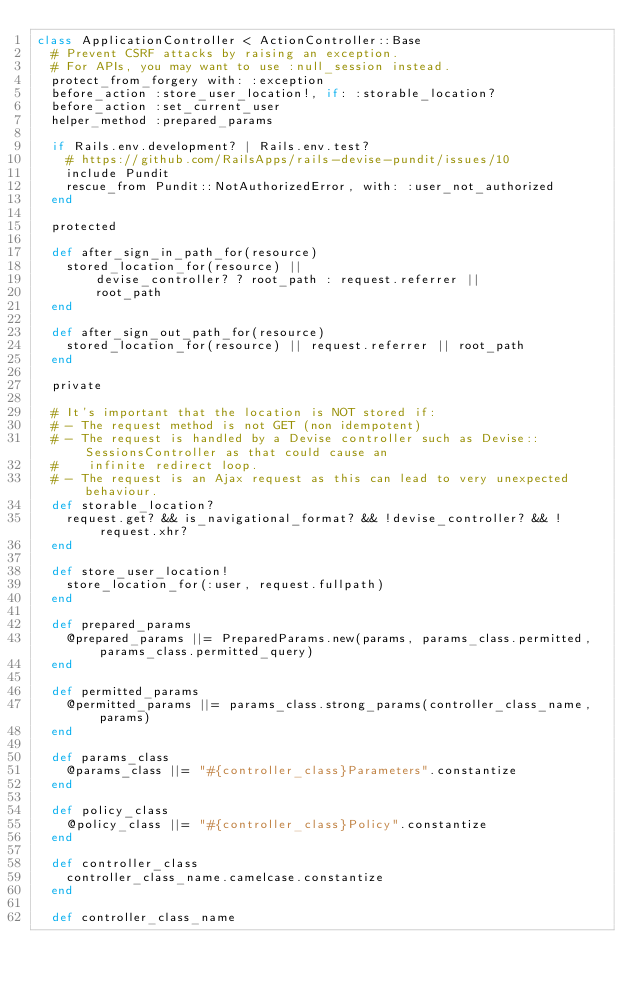<code> <loc_0><loc_0><loc_500><loc_500><_Ruby_>class ApplicationController < ActionController::Base
  # Prevent CSRF attacks by raising an exception.
  # For APIs, you may want to use :null_session instead.
  protect_from_forgery with: :exception
  before_action :store_user_location!, if: :storable_location?
  before_action :set_current_user
  helper_method :prepared_params

  if Rails.env.development? | Rails.env.test?
    # https://github.com/RailsApps/rails-devise-pundit/issues/10
    include Pundit
    rescue_from Pundit::NotAuthorizedError, with: :user_not_authorized
  end

  protected

  def after_sign_in_path_for(resource)
    stored_location_for(resource) ||
        devise_controller? ? root_path : request.referrer ||
        root_path
  end

  def after_sign_out_path_for(resource)
    stored_location_for(resource) || request.referrer || root_path
  end

  private

  # It's important that the location is NOT stored if:
  # - The request method is not GET (non idempotent)
  # - The request is handled by a Devise controller such as Devise::SessionsController as that could cause an
  #    infinite redirect loop.
  # - The request is an Ajax request as this can lead to very unexpected behaviour.
  def storable_location?
    request.get? && is_navigational_format? && !devise_controller? && !request.xhr?
  end

  def store_user_location!
    store_location_for(:user, request.fullpath)
  end

  def prepared_params
    @prepared_params ||= PreparedParams.new(params, params_class.permitted, params_class.permitted_query)
  end

  def permitted_params
    @permitted_params ||= params_class.strong_params(controller_class_name, params)
  end

  def params_class
    @params_class ||= "#{controller_class}Parameters".constantize
  end

  def policy_class
    @policy_class ||= "#{controller_class}Policy".constantize
  end

  def controller_class
    controller_class_name.camelcase.constantize
  end

  def controller_class_name</code> 